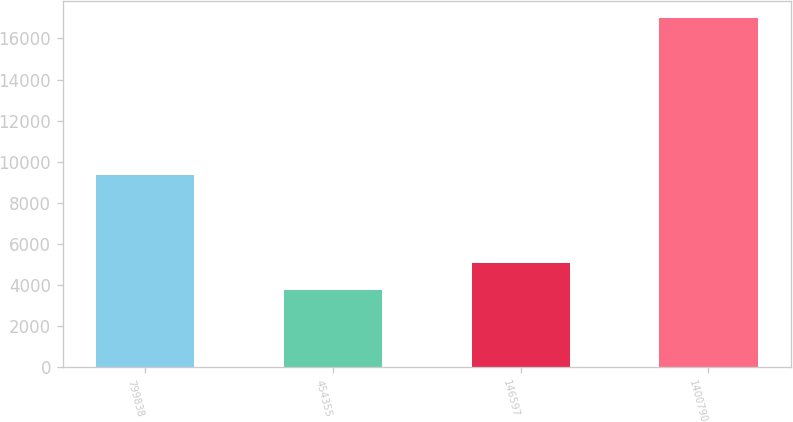Convert chart to OTSL. <chart><loc_0><loc_0><loc_500><loc_500><bar_chart><fcel>799838<fcel>454355<fcel>146597<fcel>1400790<nl><fcel>9349<fcel>3756<fcel>5079.8<fcel>16994<nl></chart> 